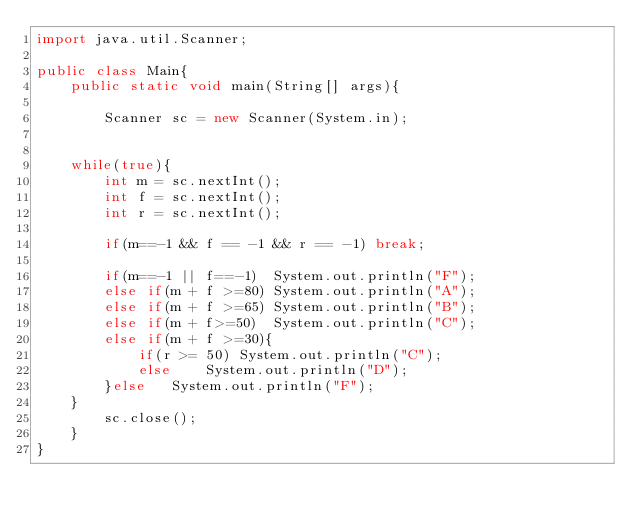Convert code to text. <code><loc_0><loc_0><loc_500><loc_500><_Java_>import java.util.Scanner;

public class Main{
    public static void main(String[] args){

        Scanner sc = new Scanner(System.in);


    while(true){
        int m = sc.nextInt();
        int f = sc.nextInt();
        int r = sc.nextInt();

        if(m==-1 && f == -1 && r == -1) break;

        if(m==-1 || f==-1)  System.out.println("F");
        else if(m + f >=80) System.out.println("A");
        else if(m + f >=65) System.out.println("B");
        else if(m + f>=50)  System.out.println("C");
        else if(m + f >=30){
            if(r >= 50) System.out.println("C");
            else    System.out.println("D");
        }else   System.out.println("F");
    }
        sc.close();
    }
}
</code> 